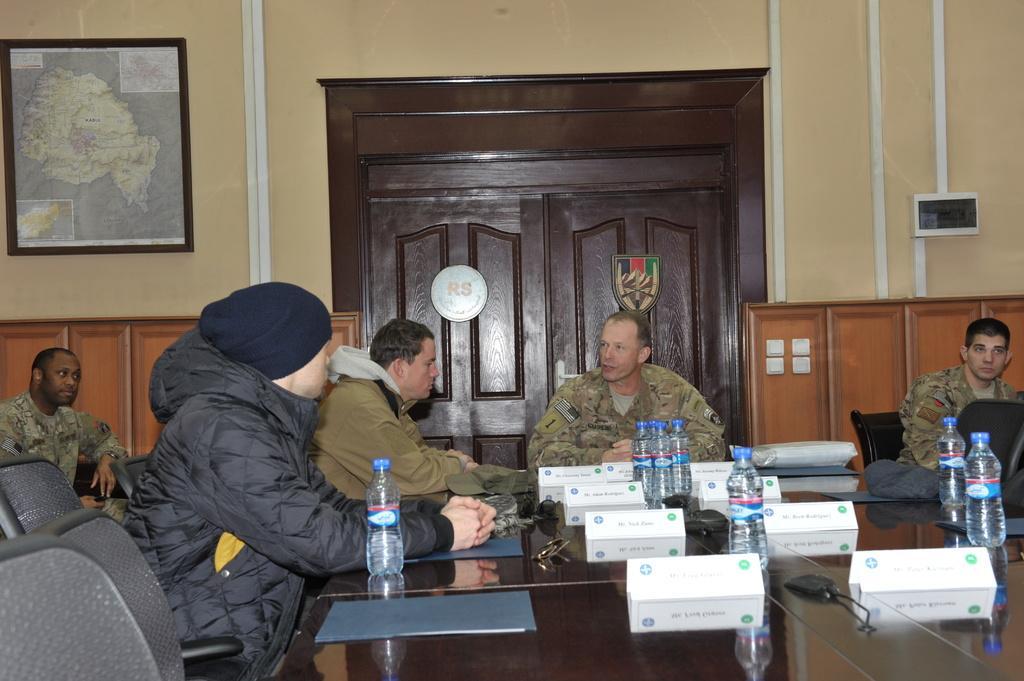Describe this image in one or two sentences. In this image I can see a table on the table I can see bottles kept on it and I can see there are few persons sitting around the table on chairs and I can see the wall at the top and I can see wooden door , on the left side I can see a wooden door attached to the wall. 